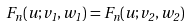Convert formula to latex. <formula><loc_0><loc_0><loc_500><loc_500>F _ { n } ( u ; v _ { 1 } , w _ { 1 } ) = F _ { n } ( u ; v _ { 2 } , w _ { 2 } )</formula> 